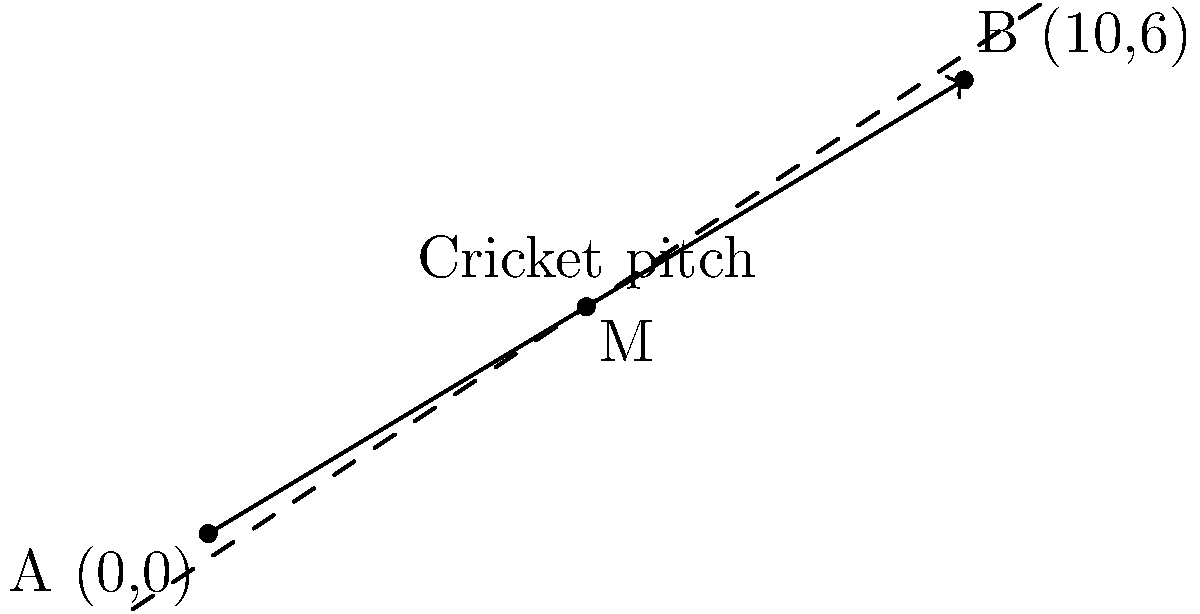In a cricket match at Eden Park, Auckland, two stumps are placed at coordinates A(0,0) and B(10,6) on a coordinate plane representing the pitch. If you need to place a marker at the midpoint of the line segment connecting these two stumps, what are the coordinates of this midpoint M? To find the midpoint of a line segment, we can use the midpoint formula:

$$ M = (\frac{x_1 + x_2}{2}, \frac{y_1 + y_2}{2}) $$

Where $(x_1, y_1)$ are the coordinates of point A and $(x_2, y_2)$ are the coordinates of point B.

Given:
- Point A: (0, 0)
- Point B: (10, 6)

Let's calculate the x-coordinate of the midpoint:
$$ x_M = \frac{x_1 + x_2}{2} = \frac{0 + 10}{2} = \frac{10}{2} = 5 $$

Now, let's calculate the y-coordinate of the midpoint:
$$ y_M = \frac{y_1 + y_2}{2} = \frac{0 + 6}{2} = \frac{6}{2} = 3 $$

Therefore, the coordinates of the midpoint M are (5, 3).
Answer: (5, 3) 